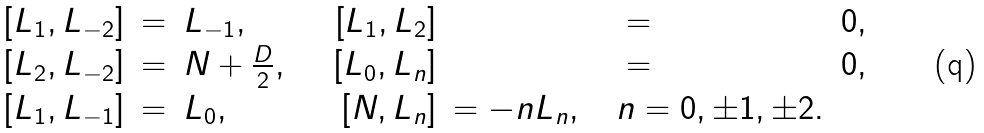<formula> <loc_0><loc_0><loc_500><loc_500>\begin{array} { r c l r c l } \left [ L _ { 1 } , L _ { - 2 } \right ] & = & L _ { - 1 } , & \quad \left [ L _ { 1 } , L _ { 2 } \right ] & = & 0 , \\ \left [ L _ { 2 } , L _ { - 2 } \right ] & = & N + \frac { D } { 2 } , & \quad \left [ L _ { 0 } , L _ { n } \right ] & = & 0 , \\ \left [ L _ { 1 } , L _ { - 1 } \right ] & = & L _ { 0 } , & \quad \left [ N , L _ { n } \right ] & = - n L _ { n } , \quad n = 0 , \pm 1 , \pm 2 . \end{array}</formula> 